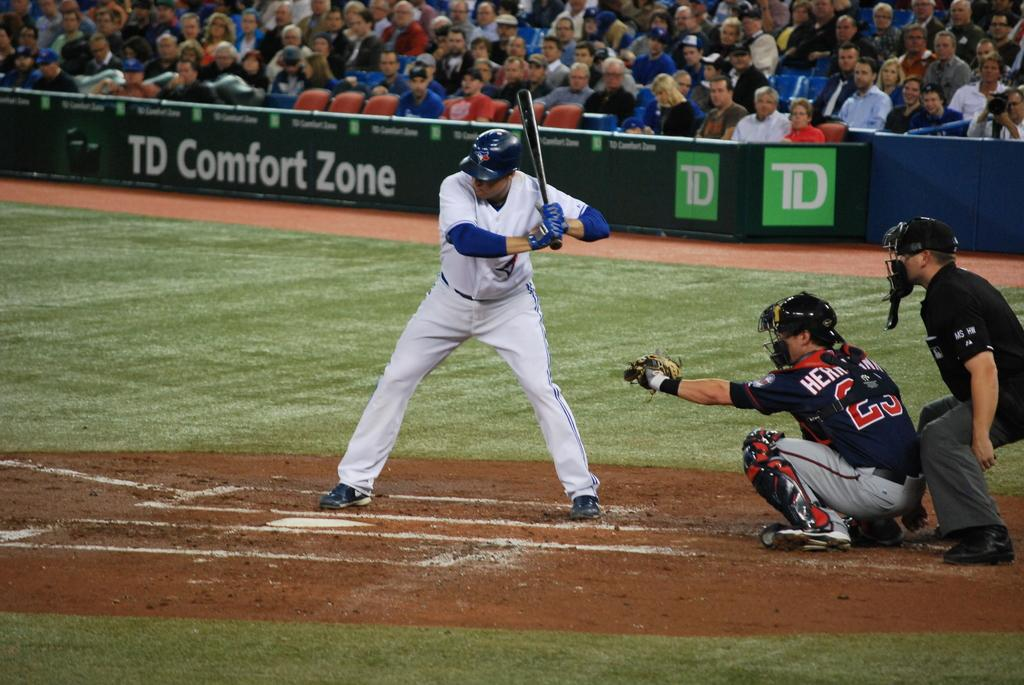<image>
Share a concise interpretation of the image provided. batter waiting for pitch and crowd watching behind banner for td comfort zone 